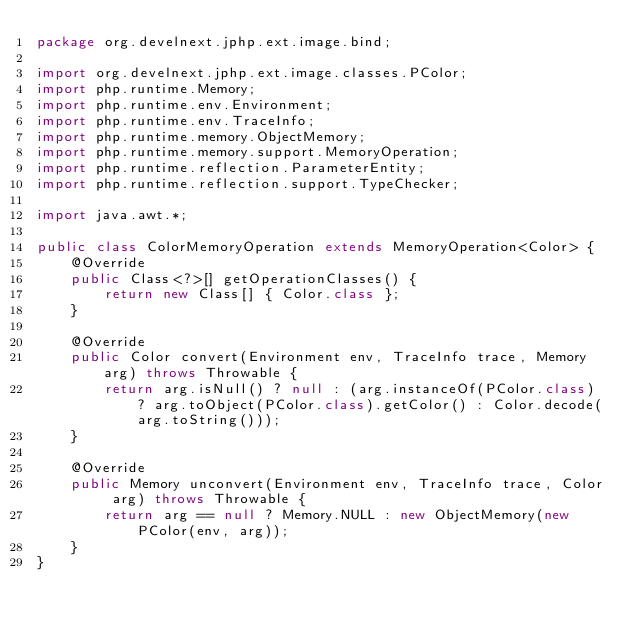Convert code to text. <code><loc_0><loc_0><loc_500><loc_500><_Java_>package org.develnext.jphp.ext.image.bind;

import org.develnext.jphp.ext.image.classes.PColor;
import php.runtime.Memory;
import php.runtime.env.Environment;
import php.runtime.env.TraceInfo;
import php.runtime.memory.ObjectMemory;
import php.runtime.memory.support.MemoryOperation;
import php.runtime.reflection.ParameterEntity;
import php.runtime.reflection.support.TypeChecker;

import java.awt.*;

public class ColorMemoryOperation extends MemoryOperation<Color> {
    @Override
    public Class<?>[] getOperationClasses() {
        return new Class[] { Color.class };
    }

    @Override
    public Color convert(Environment env, TraceInfo trace, Memory arg) throws Throwable {
        return arg.isNull() ? null : (arg.instanceOf(PColor.class) ? arg.toObject(PColor.class).getColor() : Color.decode(arg.toString()));
    }

    @Override
    public Memory unconvert(Environment env, TraceInfo trace, Color arg) throws Throwable {
        return arg == null ? Memory.NULL : new ObjectMemory(new PColor(env, arg));
    }
}
</code> 